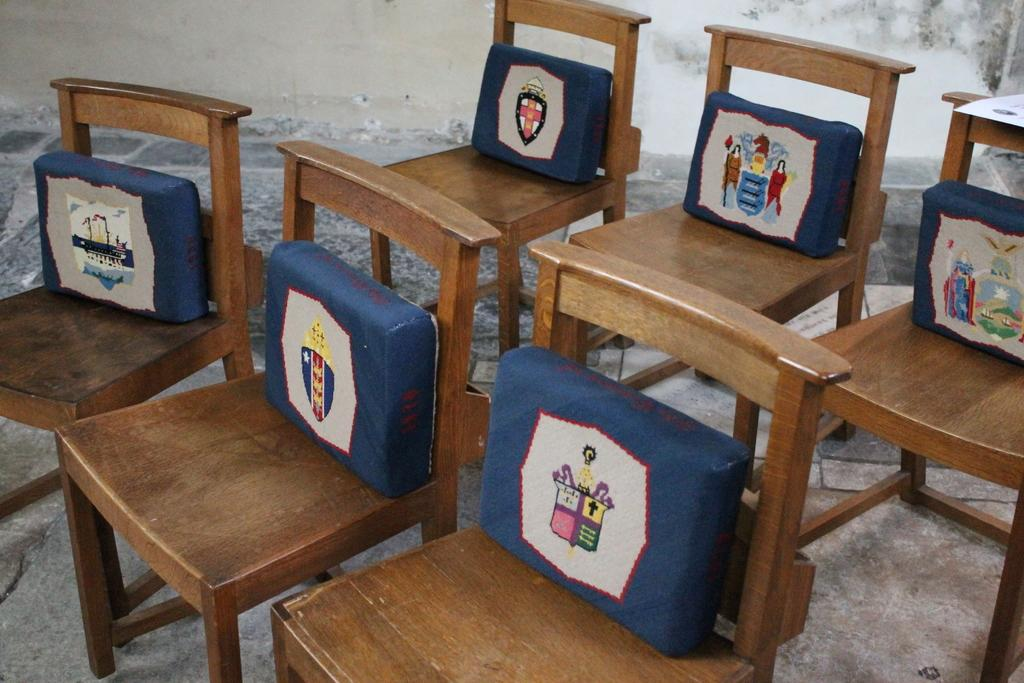What type of furniture is visible in the image? There are wooden chairs in the image. What is placed on the wooden chairs? Cushions are placed on the chairs. What design or pattern can be seen on the cushions? The cushions have symbols on them. What is visible in the background of the image? There is a wall in the background of the image. How does the stranger say good-bye to the chairs in the image? There is no stranger present in the image, and therefore no interaction with the chairs can be observed. 